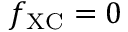<formula> <loc_0><loc_0><loc_500><loc_500>f _ { X C } = 0</formula> 